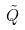<formula> <loc_0><loc_0><loc_500><loc_500>\tilde { Q }</formula> 